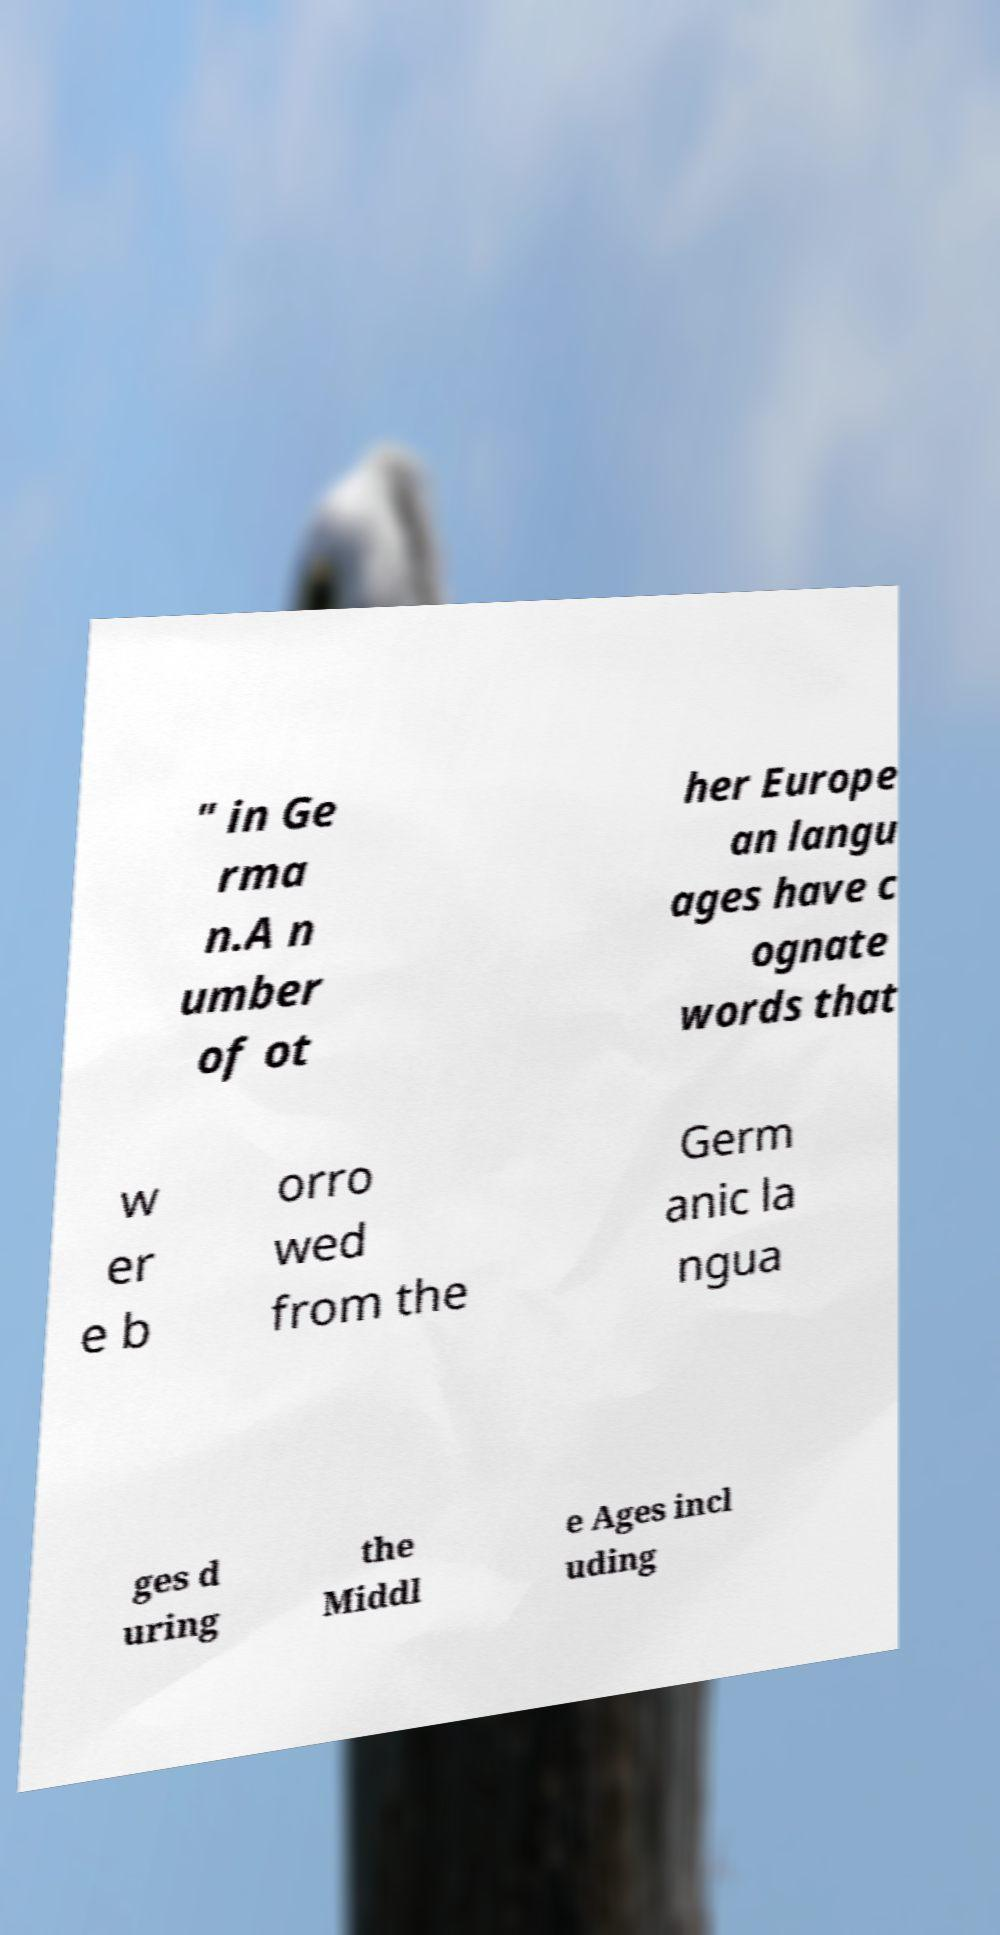Please read and relay the text visible in this image. What does it say? " in Ge rma n.A n umber of ot her Europe an langu ages have c ognate words that w er e b orro wed from the Germ anic la ngua ges d uring the Middl e Ages incl uding 